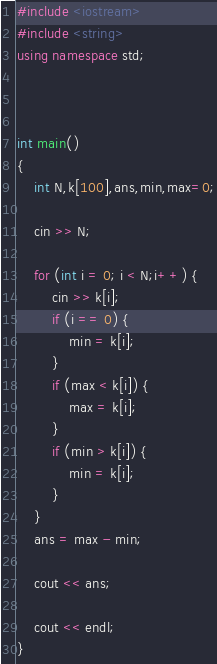<code> <loc_0><loc_0><loc_500><loc_500><_C++_>

#include <iostream>
#include <string>
using namespace std;



int main()
{
    int N,k[100],ans,min,max=0;

    cin >> N;
    
    for (int i = 0; i < N;i++) {
        cin >> k[i];
        if (i == 0) {
            min = k[i];
        }
        if (max < k[i]) {
            max = k[i];
        }
        if (min > k[i]) {
            min = k[i];
        }
    }
    ans = max - min;

    cout << ans;
        
    cout << endl;
}</code> 